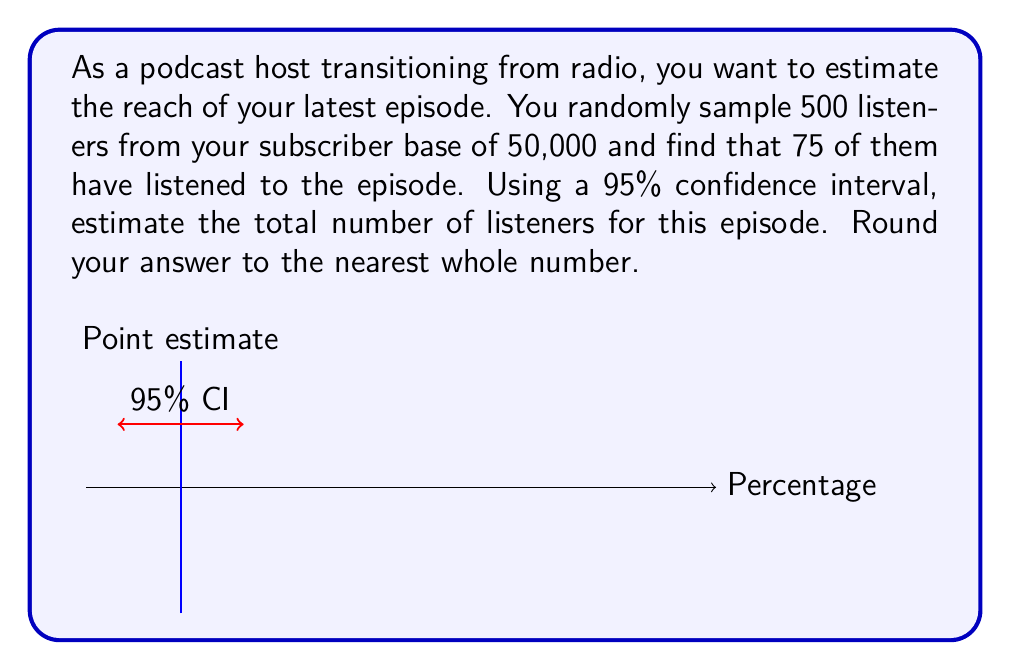What is the answer to this math problem? Let's approach this step-by-step:

1) First, we calculate the sample proportion:
   $p = \frac{75}{500} = 0.15$ or 15%

2) The standard error for a proportion is given by:
   $SE = \sqrt{\frac{p(1-p)}{n}}$
   where $n$ is the sample size.

   $SE = \sqrt{\frac{0.15(1-0.15)}{500}} = 0.0159$

3) For a 95% confidence interval, we use a z-score of 1.96. The margin of error is:
   $ME = 1.96 * SE = 1.96 * 0.0159 = 0.0312$

4) The confidence interval for the proportion is:
   $0.15 \pm 0.0312$, or $(0.1188, 0.1812)$

5) To estimate the total number of listeners, we multiply these proportions by the total subscriber base:
   Lower bound: $0.1188 * 50,000 = 5,940$
   Upper bound: $0.1812 * 50,000 = 9,060$

6) The point estimate is:
   $0.15 * 50,000 = 7,500$

Therefore, we can estimate with 95% confidence that the number of listeners for this episode is between 5,940 and 9,060, with a point estimate of 7,500.
Answer: 7,500 listeners (95% CI: 5,940 to 9,060) 